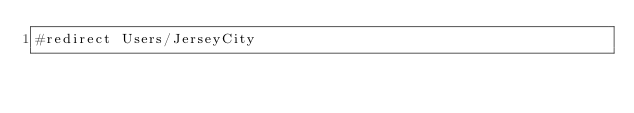<code> <loc_0><loc_0><loc_500><loc_500><_FORTRAN_>#redirect Users/JerseyCity
</code> 